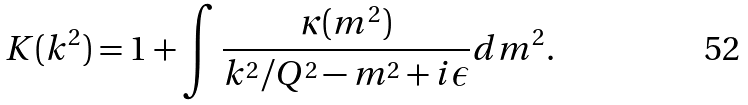Convert formula to latex. <formula><loc_0><loc_0><loc_500><loc_500>K ( k ^ { 2 } ) = 1 + \int \frac { \kappa ( m ^ { 2 } ) } { k ^ { 2 } / Q ^ { 2 } - m ^ { 2 } + i \epsilon } d m ^ { 2 } .</formula> 